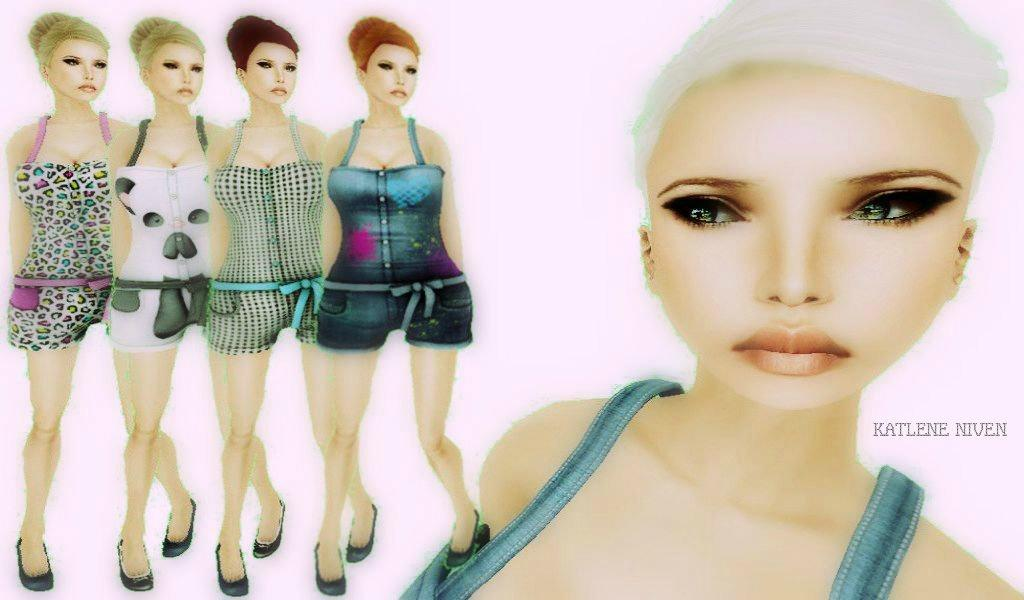How many women are present in the image? There are five women in the image. What are the women doing in the image? The women are standing. What type of image is it, based on the provided fact? The image appears to be animated. Where can text be found in the image? There is some text on the right side of the image. What type of star can be seen in the image? There is no star present in the image. How many wheels are visible in the image? There are no wheels visible in the image. 